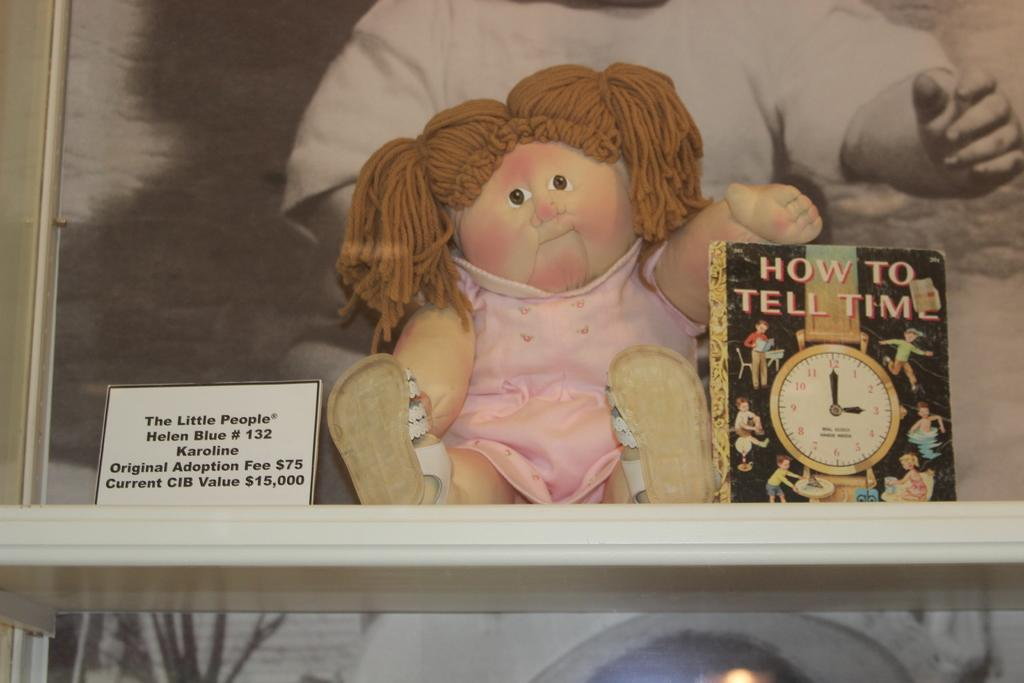<image>
Write a terse but informative summary of the picture. Someone is looking at the book how to tell time. 